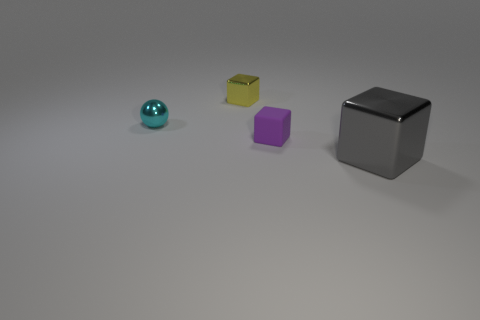Subtract all big gray shiny blocks. How many blocks are left? 2 Add 2 tiny yellow shiny objects. How many objects exist? 6 Subtract 1 spheres. How many spheres are left? 0 Subtract all balls. How many objects are left? 3 Add 4 cyan metal balls. How many cyan metal balls are left? 5 Add 4 tiny shiny things. How many tiny shiny things exist? 6 Subtract 0 blue cylinders. How many objects are left? 4 Subtract all green blocks. Subtract all gray cylinders. How many blocks are left? 3 Subtract all purple balls. How many green cubes are left? 0 Subtract all tiny cyan shiny balls. Subtract all small rubber objects. How many objects are left? 2 